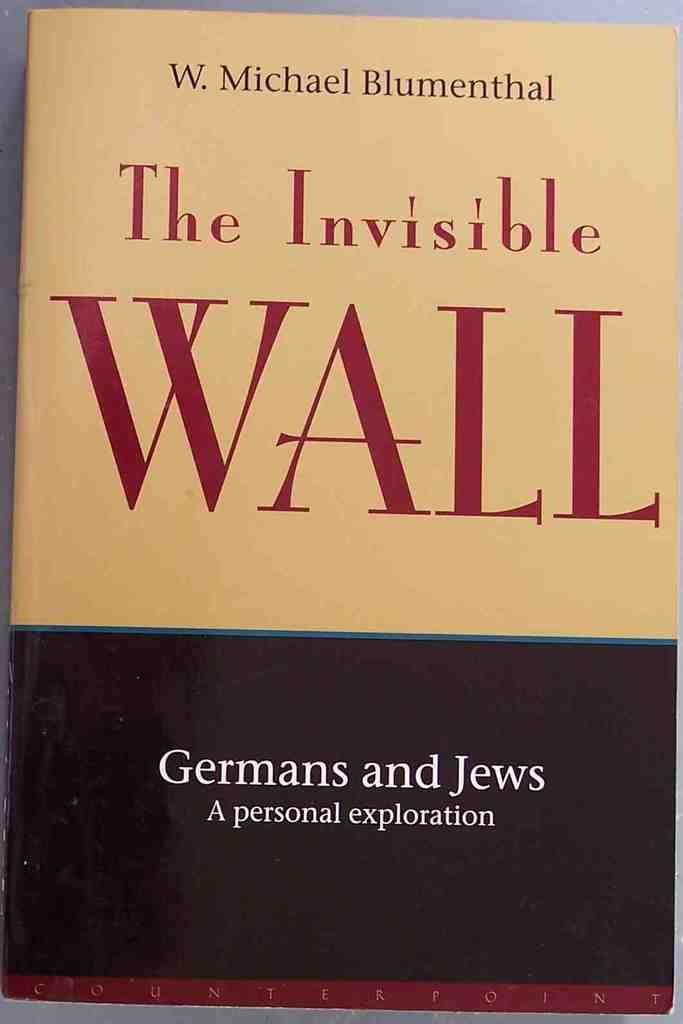<image>
Provide a brief description of the given image. A book titled The Invisible Wall, written by W. Michael Blumenthal. 